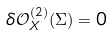Convert formula to latex. <formula><loc_0><loc_0><loc_500><loc_500>\delta \mathcal { O } ^ { ( 2 ) } _ { X } ( \Sigma ) = 0</formula> 